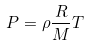<formula> <loc_0><loc_0><loc_500><loc_500>P = \rho \frac { R } { M } T</formula> 